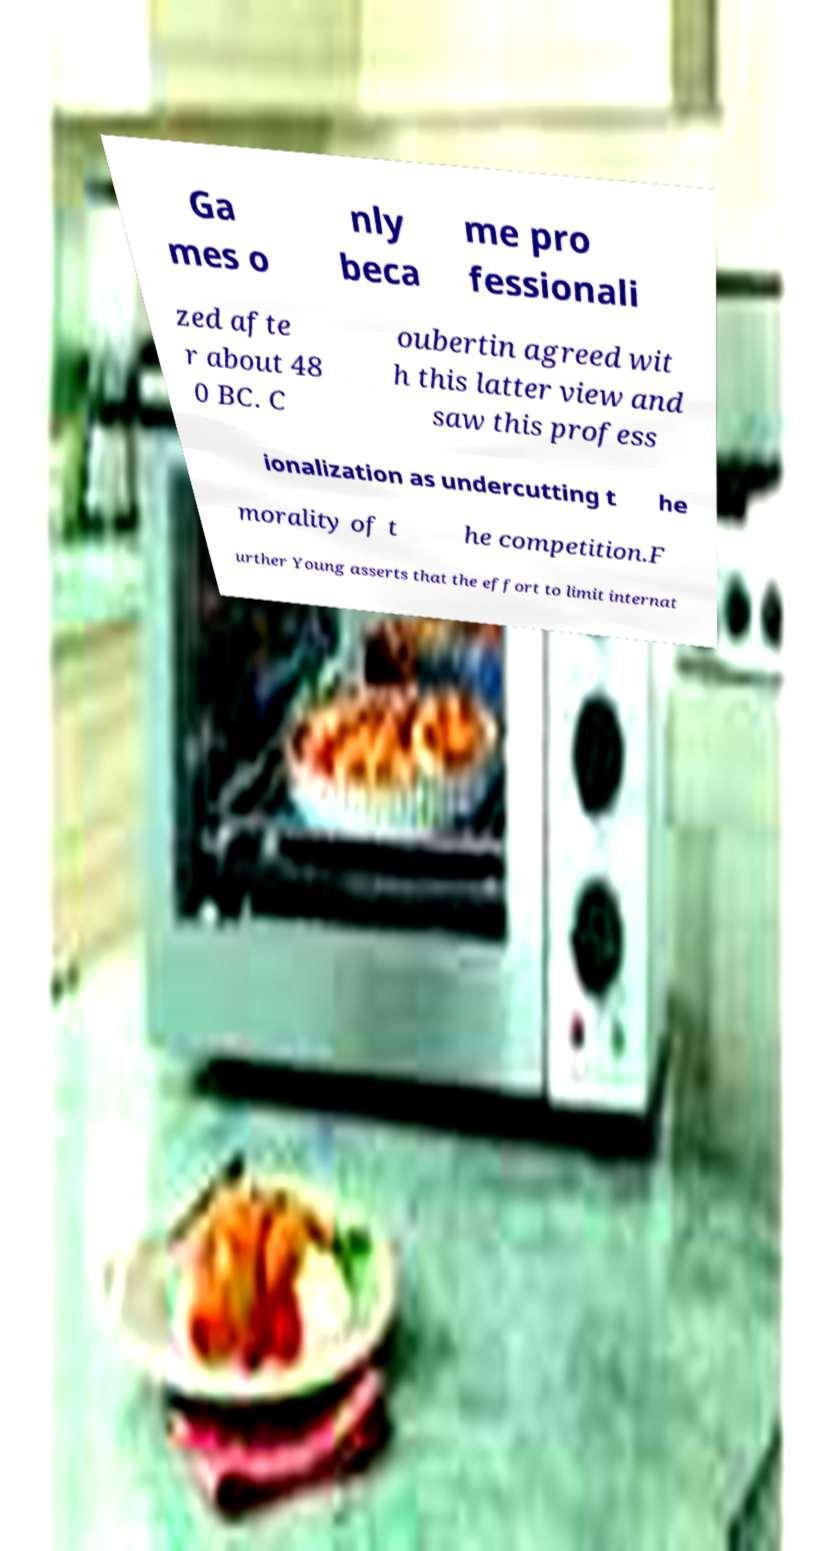There's text embedded in this image that I need extracted. Can you transcribe it verbatim? Ga mes o nly beca me pro fessionali zed afte r about 48 0 BC. C oubertin agreed wit h this latter view and saw this profess ionalization as undercutting t he morality of t he competition.F urther Young asserts that the effort to limit internat 